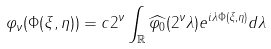Convert formula to latex. <formula><loc_0><loc_0><loc_500><loc_500>\varphi _ { \nu } ( \Phi ( \xi , \eta ) ) = c 2 ^ { \nu } \int _ { \mathbb { R } } \widehat { \varphi _ { 0 } } ( 2 ^ { \nu } \lambda ) e ^ { i \lambda \Phi ( \xi , \eta ) } d \lambda</formula> 